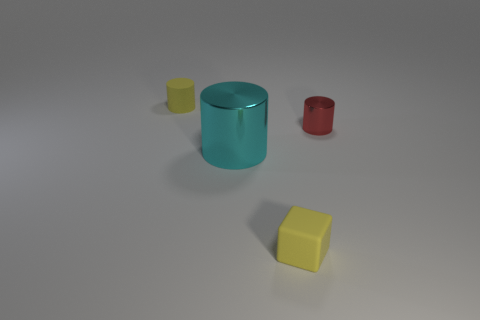Add 2 small yellow rubber cylinders. How many objects exist? 6 Subtract all cylinders. How many objects are left? 1 Add 4 shiny things. How many shiny things exist? 6 Subtract 1 yellow cylinders. How many objects are left? 3 Subtract all large cubes. Subtract all tiny yellow things. How many objects are left? 2 Add 2 small shiny cylinders. How many small shiny cylinders are left? 3 